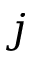Convert formula to latex. <formula><loc_0><loc_0><loc_500><loc_500>j</formula> 